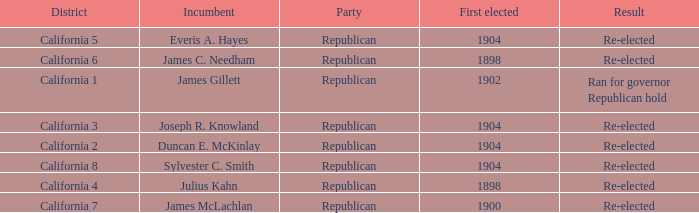Which Incumbent has a District of California 5? Everis A. Hayes. 